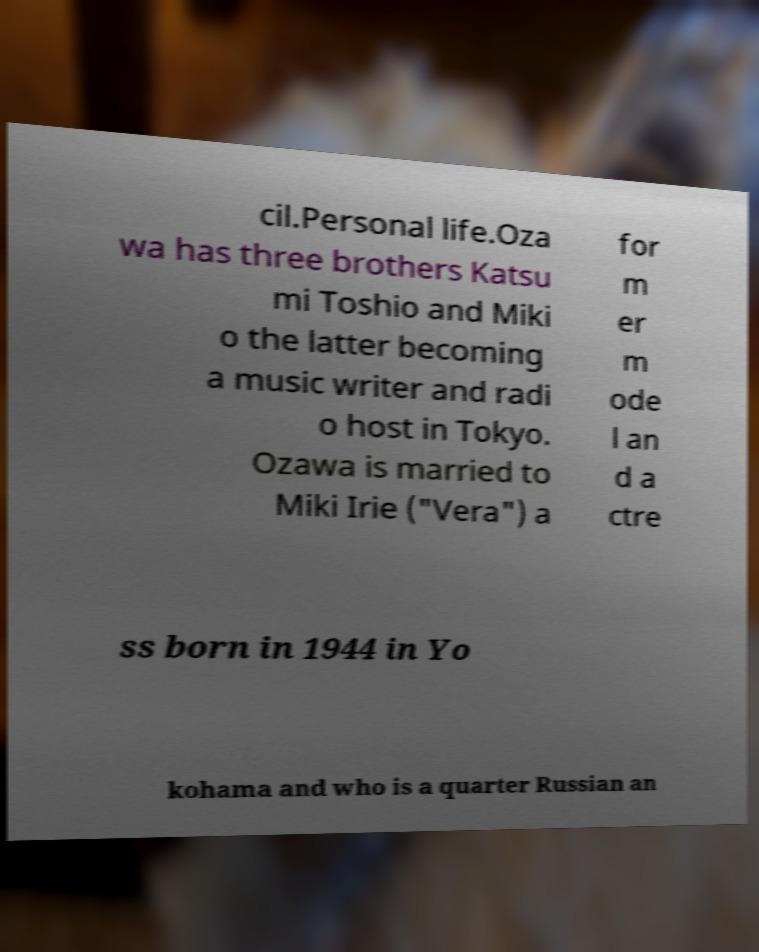Can you accurately transcribe the text from the provided image for me? cil.Personal life.Oza wa has three brothers Katsu mi Toshio and Miki o the latter becoming a music writer and radi o host in Tokyo. Ozawa is married to Miki Irie ("Vera") a for m er m ode l an d a ctre ss born in 1944 in Yo kohama and who is a quarter Russian an 